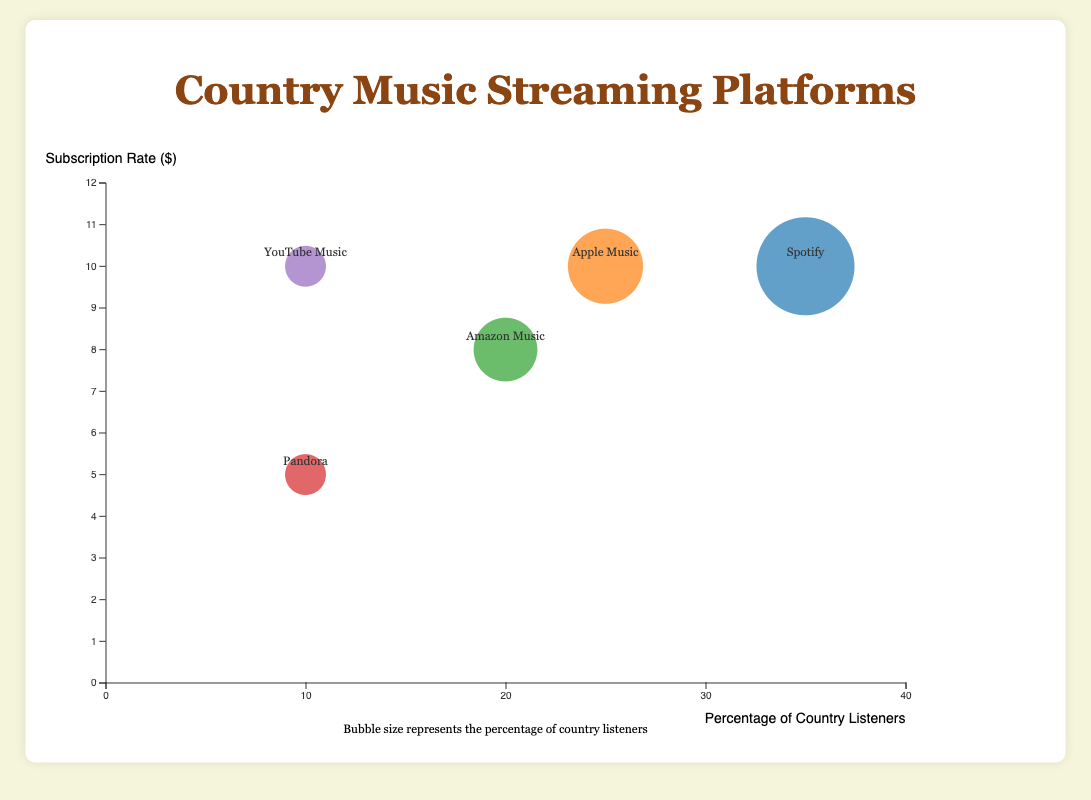What's the most used streaming platform among country music listeners? By examining the position and size of the bubbles, the largest bubble represents Spotify, which has the highest percentage of country music listeners at 35%.
Answer: Spotify Which streaming platform has the highest subscription rate? By looking at the y-axis (subscription rate), all platforms except for Pandora have the same highest rate of $9.99. Among them are Spotify, Apple Music, and YouTube Music.
Answer: Spotify, Apple Music, YouTube Music What percentage of country listeners use YouTube Music? By locating the YouTube Music bubble and referring to its position on the x-axis, YouTube Music has 10% of country listeners.
Answer: 10% What is the age demographic of Amazon Music listeners? By finding Amazon Music's bubble and reading the demographic information, Amazon Music listeners are primarily aged 35-54.
Answer: 35-54 How does the subscription rate of Pandora compare to other platforms? By observing the y-axis, Pandora has the lowest subscription rate at $4.99 compared to the other platforms, which have rates of either $7.99 or $9.99.
Answer: It is the lowest Which streaming platform has the smallest bubble? The smallest bubbles indicate the platforms with the least percentage of country music listeners. Pandora and YouTube Music both have the smallest bubbles, representing 10% each.
Answer: Pandora, YouTube Music What is the total percentage of country listeners across all platforms? Add the percentages of country listeners for all platforms: 35% (Spotify) + 25% (Apple Music) + 20% (Amazon Music) + 10% (Pandora) + 10% (YouTube Music) = 100%.
Answer: 100% Which age demographic is served by the highest number of streaming platforms? Look at the age demographic associated with each platform. The 18-34 demographic appears for Spotify and overlaps with YouTube Music’s 18-24 demographic. Thus it includes three platforms: Spotify, Apple Music, YouTube Music.
Answer: 18-34 Compare the subscription rates and country listener percentages for Apple Music and Amazon Music. Apple Music's subscription rate is $9.99 and it has 25% of country listeners, while Amazon Music's subscription rate is $7.99 with 20% of country listeners. Apple Music has a higher subscription rate and percentage of listeners.
Answer: Apple Music has higher rates and listener percentage Which platform targets the youngest demographic, and what percentage of country music listeners use it? The youngest demographic is 18-24, served by YouTube Music, which has 10% of country music listeners.
Answer: YouTube Music, 10% 